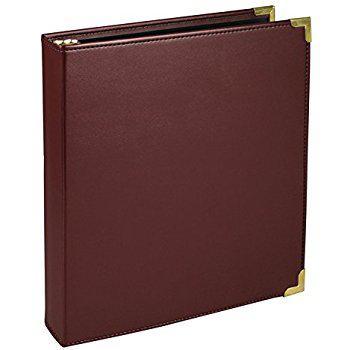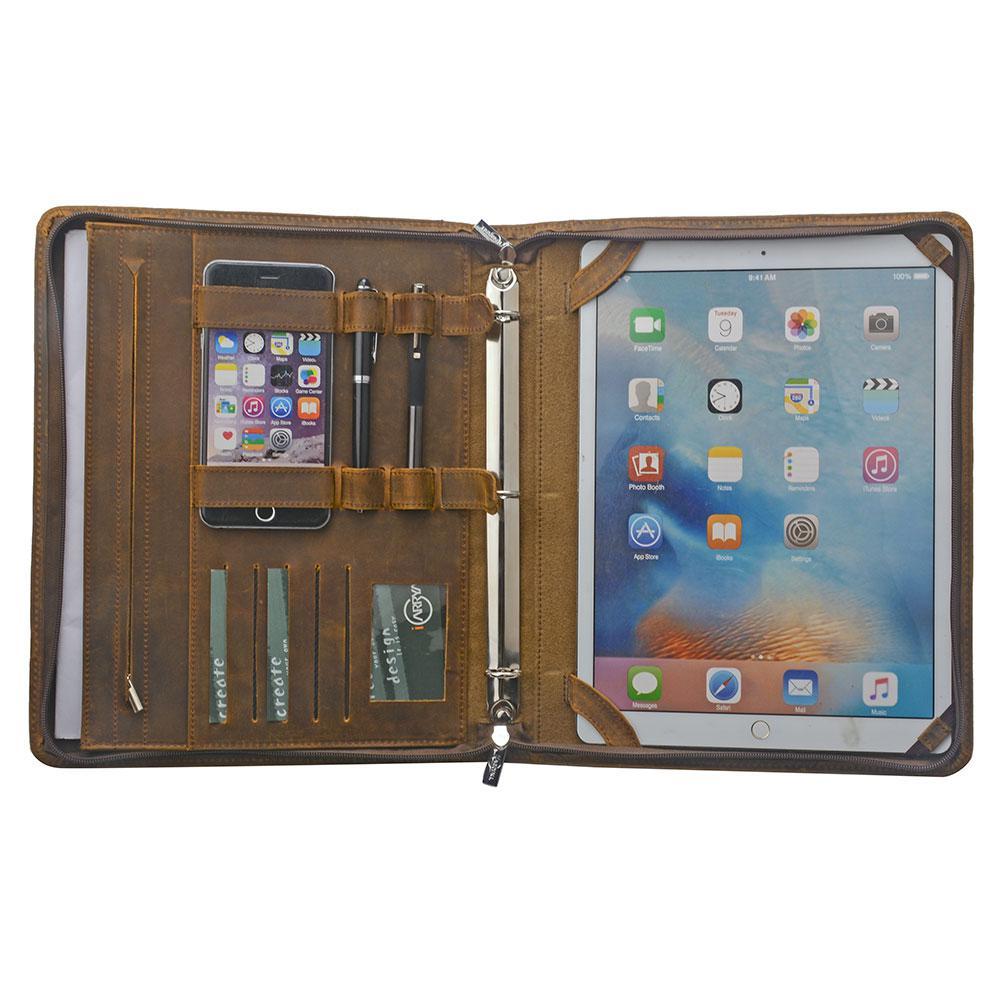The first image is the image on the left, the second image is the image on the right. Considering the images on both sides, is "Two leather binders are shown, one closed and the other open flat, showing its interior layout." valid? Answer yes or no. Yes. The first image is the image on the left, the second image is the image on the right. Given the left and right images, does the statement "An image shows a single upright binder, which is dark burgundy-brownish in color." hold true? Answer yes or no. Yes. 